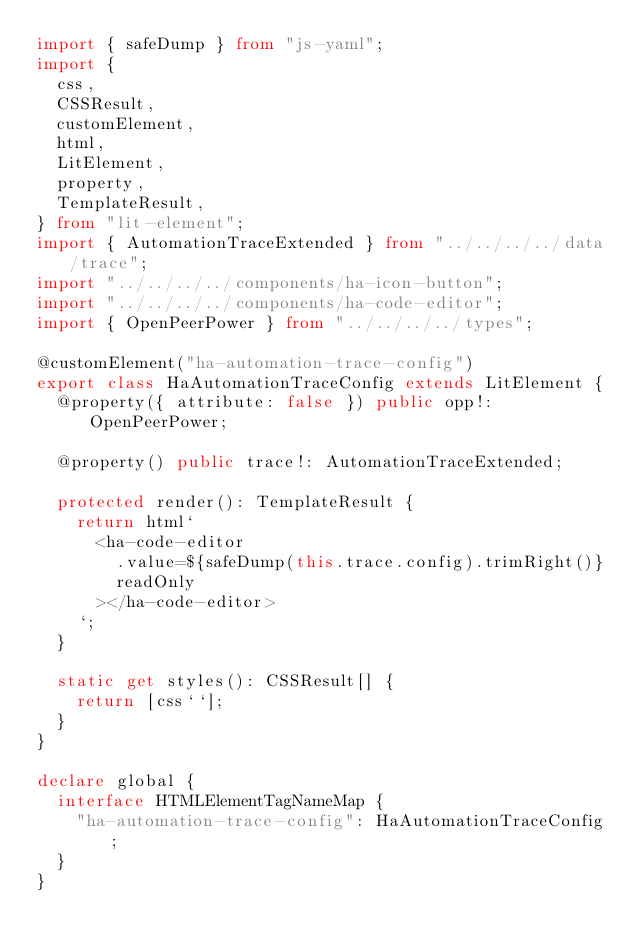<code> <loc_0><loc_0><loc_500><loc_500><_TypeScript_>import { safeDump } from "js-yaml";
import {
  css,
  CSSResult,
  customElement,
  html,
  LitElement,
  property,
  TemplateResult,
} from "lit-element";
import { AutomationTraceExtended } from "../../../../data/trace";
import "../../../../components/ha-icon-button";
import "../../../../components/ha-code-editor";
import { OpenPeerPower } from "../../../../types";

@customElement("ha-automation-trace-config")
export class HaAutomationTraceConfig extends LitElement {
  @property({ attribute: false }) public opp!: OpenPeerPower;

  @property() public trace!: AutomationTraceExtended;

  protected render(): TemplateResult {
    return html`
      <ha-code-editor
        .value=${safeDump(this.trace.config).trimRight()}
        readOnly
      ></ha-code-editor>
    `;
  }

  static get styles(): CSSResult[] {
    return [css``];
  }
}

declare global {
  interface HTMLElementTagNameMap {
    "ha-automation-trace-config": HaAutomationTraceConfig;
  }
}
</code> 